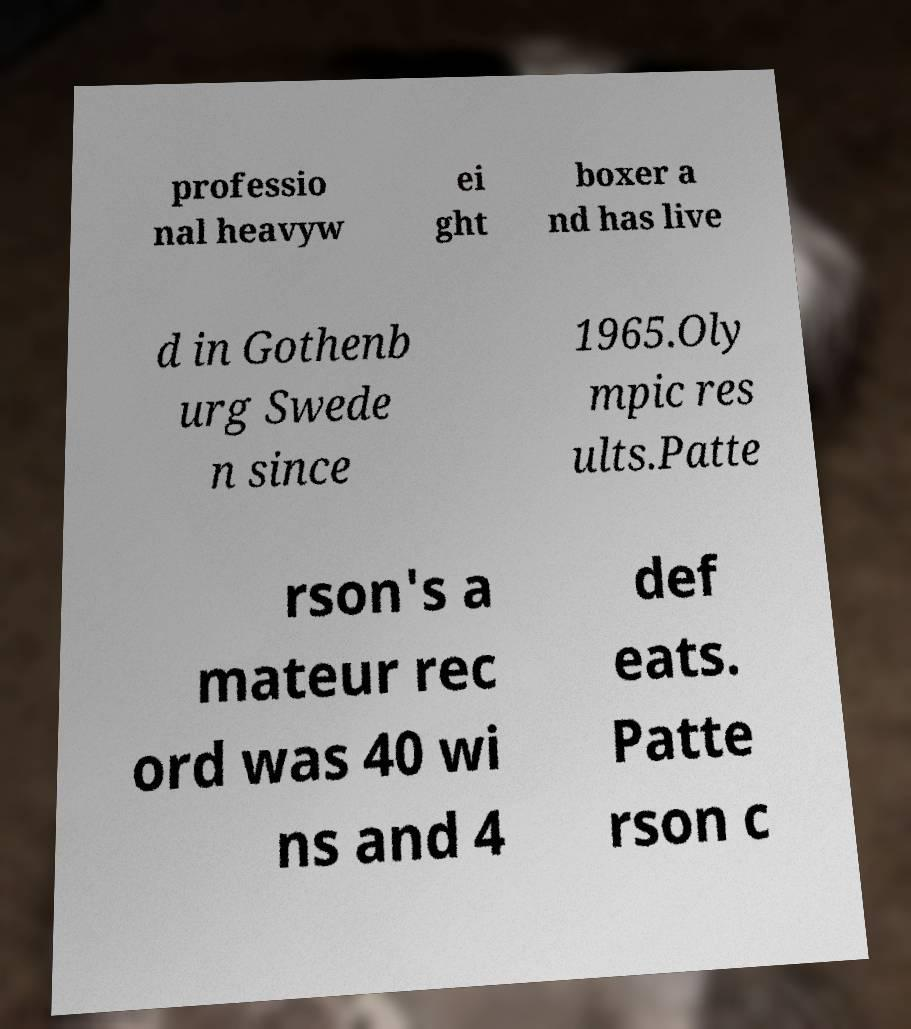Can you read and provide the text displayed in the image?This photo seems to have some interesting text. Can you extract and type it out for me? professio nal heavyw ei ght boxer a nd has live d in Gothenb urg Swede n since 1965.Oly mpic res ults.Patte rson's a mateur rec ord was 40 wi ns and 4 def eats. Patte rson c 